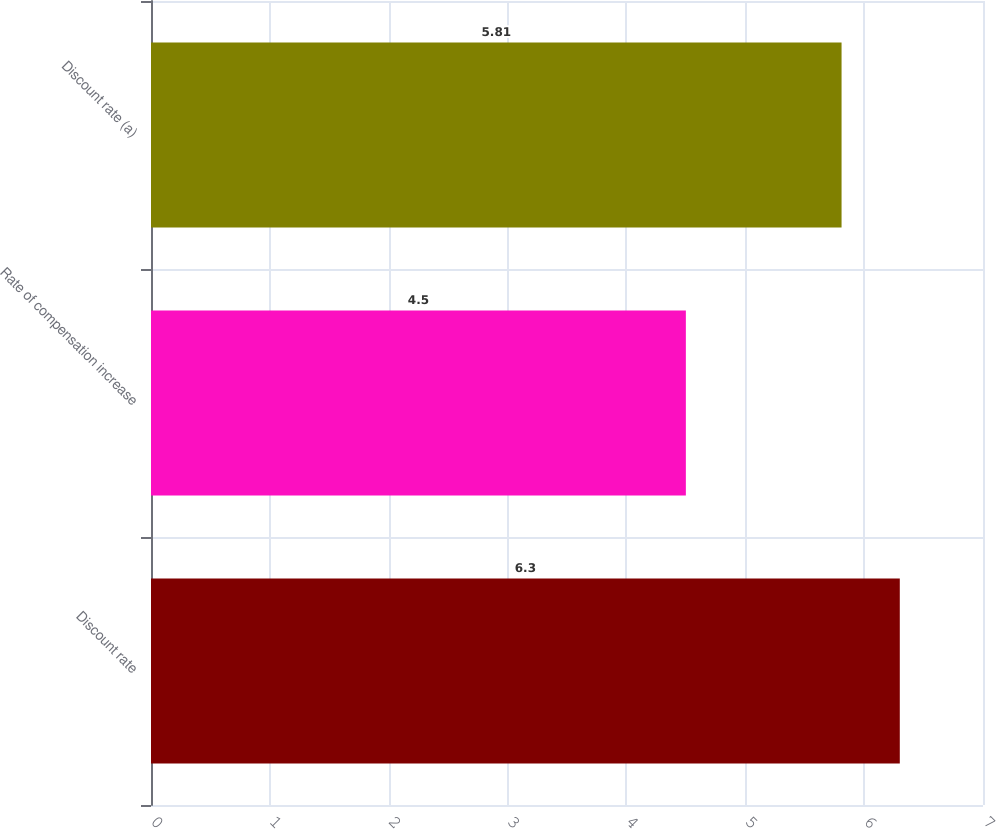Convert chart. <chart><loc_0><loc_0><loc_500><loc_500><bar_chart><fcel>Discount rate<fcel>Rate of compensation increase<fcel>Discount rate (a)<nl><fcel>6.3<fcel>4.5<fcel>5.81<nl></chart> 